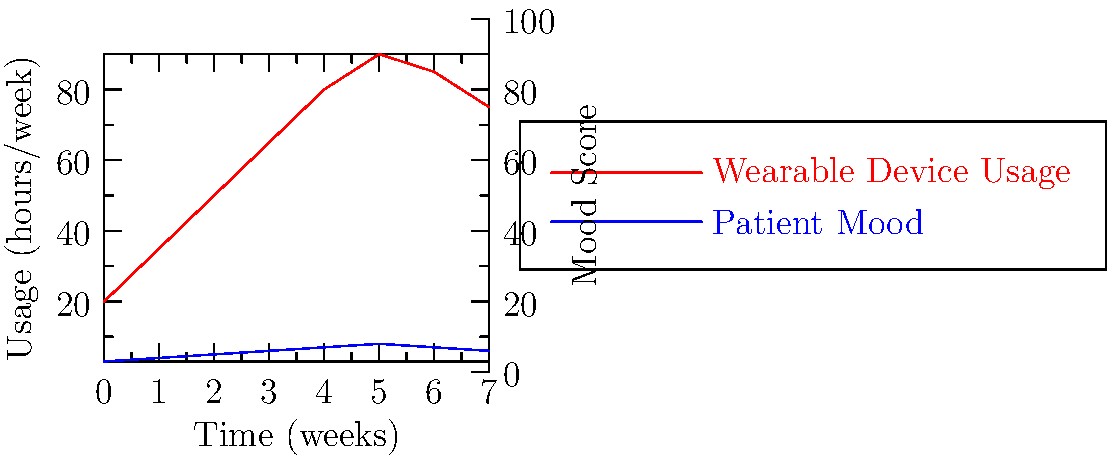Based on the time series graph showing the correlation between wearable device usage and patient mood fluctuations over 8 weeks, at which point does the patient's mood score peak, and how does this relate to the device usage trend? To answer this question, we need to analyze the graph step-by-step:

1. Identify the two data series:
   - Red line: Wearable Device Usage (hours/week)
   - Blue line: Patient Mood Score

2. Examine the Patient Mood Score (blue line):
   - The mood score starts at 3 in week 0
   - It gradually increases until it reaches its peak
   - The highest point on the blue line is at week 5

3. Correlate the peak mood score with device usage:
   - At week 5, the mood score is at its maximum (8)
   - The device usage (red line) is also near its peak at this point

4. Analyze the device usage trend:
   - Device usage increases steadily from week 0 to week 5
   - It reaches its maximum at week 5 (90 hours/week)
   - After week 5, there's a slight decrease in usage

5. Interpret the relationship:
   - The peak in mood score coincides with the peak in device usage
   - This suggests a positive correlation between device usage and mood improvement
   - However, after week 5, both mood and usage slightly decline, indicating a potential plateau effect
Answer: Week 5; maximum device usage 